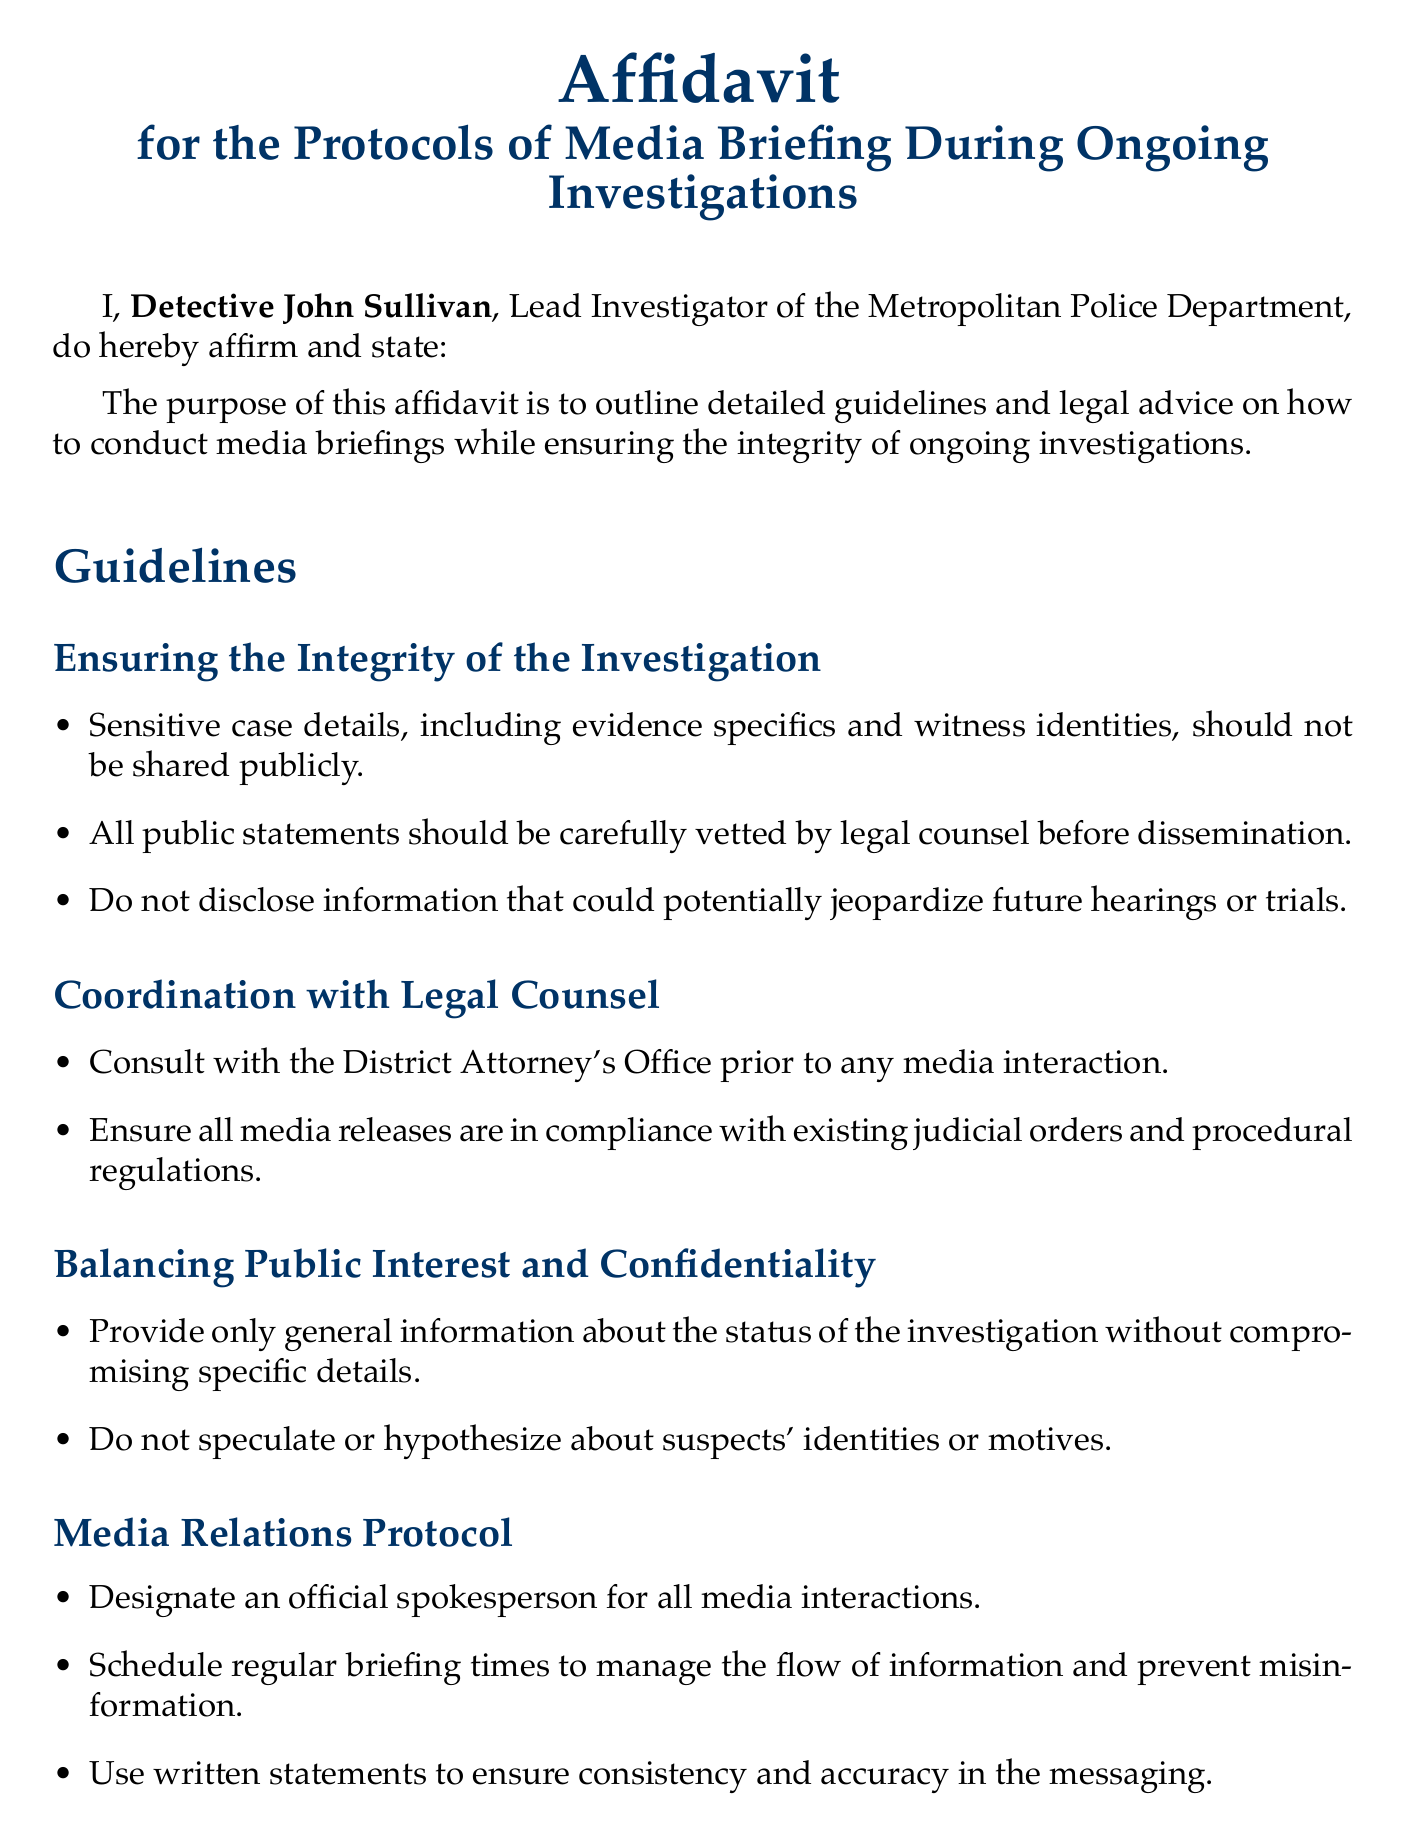What is the name of the affiant? The affiant's name is mentioned at the beginning of the document as the Lead Investigator.
Answer: Detective John Sullivan What should be shared publicly according to the guidelines? The guidelines state that sensitive case details should not be shared publicly, specifically mentioning evidence specifics and witness identities.
Answer: Sensitive case details What is the designated role for media interactions? The document specifies a role to manage media interactions to ensure consistency.
Answer: Official spokesperson What should be maintained regarding statements made to the media? The document emphasizes the importance of keeping a record of communications to ensure accountability.
Answer: Record of all statements How many items are listed under "Specific Do's and Don'ts"? The document highlights the requirements in two categories - Do's and Don'ts for media engagement.
Answer: Two categories Which legal obligations must be adhered to during media briefings? The document outlines several legal guidelines, prominently mentioning adherence to FOIA guidelines and privacy laws.
Answer: FOIA guidelines What must be avoided when discussing suspects? The document clearly states a prohibition regarding discussing suspects prior to formal charges being filed, to protect the integrity of the investigation.
Answer: Release information on suspects What is the color of the document's title? The title color is specified in the document to present a professional appearance.
Answer: Deep blue How should the media briefing information be distributed? The document advises a structured approach to media information flow, specifically recommending written statements for accuracy.
Answer: Written statements 